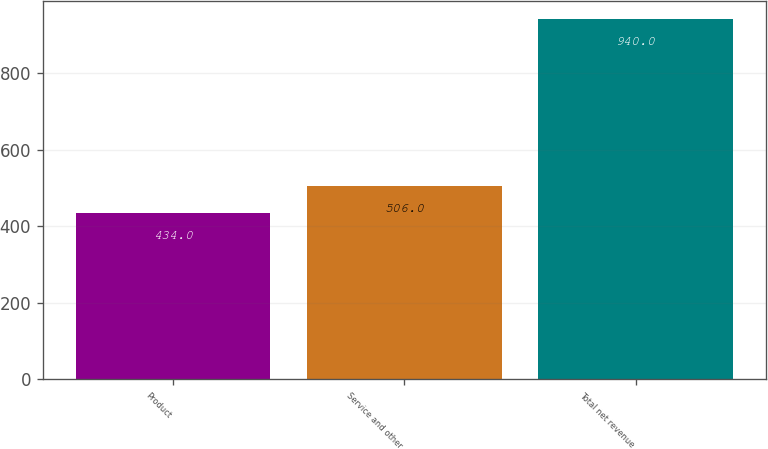<chart> <loc_0><loc_0><loc_500><loc_500><bar_chart><fcel>Product<fcel>Service and other<fcel>Total net revenue<nl><fcel>434<fcel>506<fcel>940<nl></chart> 